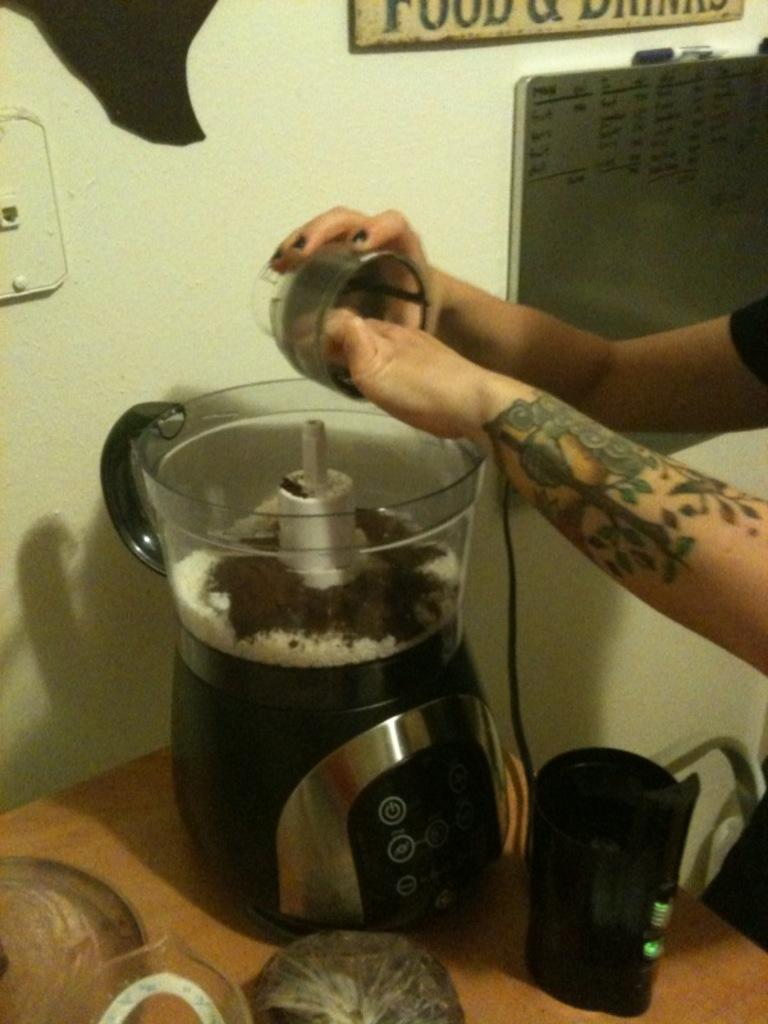What is the person in the image doing? The person is putting ingredients in a blender. Where is the blender located in the image? The blender is on top of a table. What type of reward does the bat receive after using the swing in the image? There is no bat or swing present in the image; it features a person putting ingredients in a blender on top of a table. 